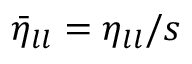Convert formula to latex. <formula><loc_0><loc_0><loc_500><loc_500>\bar { \eta } _ { l l } = \eta _ { l l } / s</formula> 